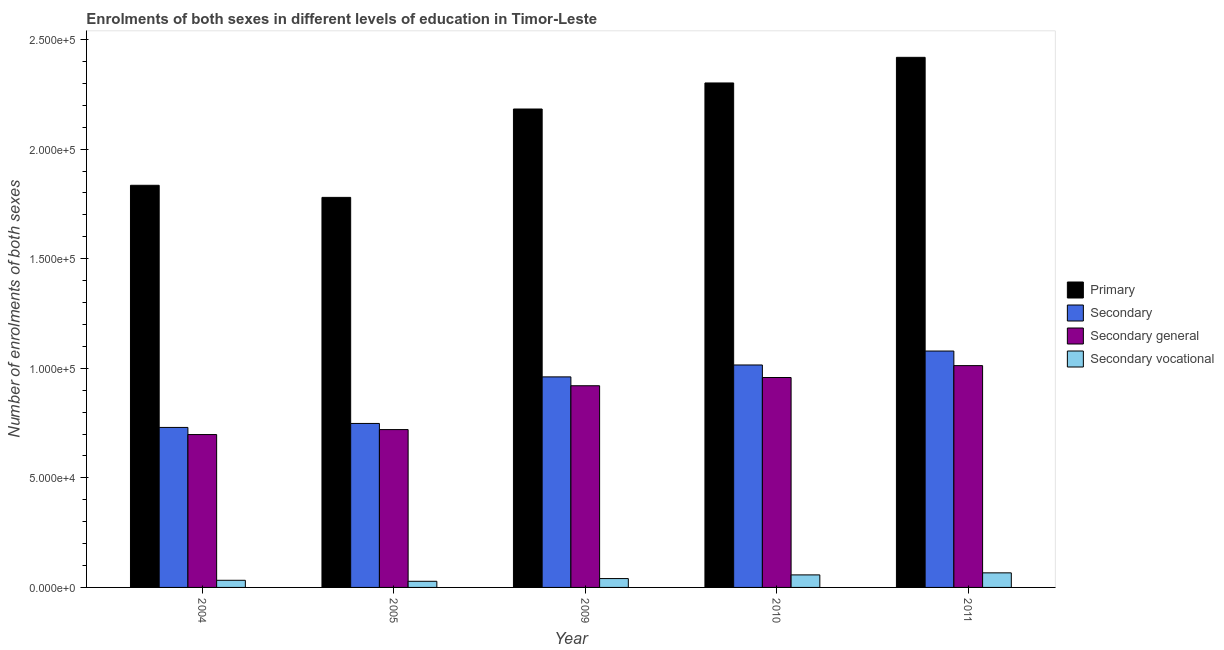Are the number of bars per tick equal to the number of legend labels?
Offer a terse response. Yes. How many bars are there on the 1st tick from the right?
Provide a succinct answer. 4. What is the label of the 5th group of bars from the left?
Offer a very short reply. 2011. What is the number of enrolments in secondary education in 2005?
Ensure brevity in your answer.  7.48e+04. Across all years, what is the maximum number of enrolments in secondary vocational education?
Give a very brief answer. 6649. Across all years, what is the minimum number of enrolments in secondary vocational education?
Ensure brevity in your answer.  2800. In which year was the number of enrolments in secondary general education maximum?
Give a very brief answer. 2011. What is the total number of enrolments in secondary vocational education in the graph?
Your answer should be compact. 2.25e+04. What is the difference between the number of enrolments in secondary education in 2004 and that in 2010?
Offer a terse response. -2.85e+04. What is the difference between the number of enrolments in secondary general education in 2009 and the number of enrolments in primary education in 2004?
Keep it short and to the point. 2.23e+04. What is the average number of enrolments in primary education per year?
Your response must be concise. 2.10e+05. In how many years, is the number of enrolments in secondary education greater than 200000?
Give a very brief answer. 0. What is the ratio of the number of enrolments in secondary education in 2004 to that in 2011?
Keep it short and to the point. 0.68. Is the number of enrolments in secondary vocational education in 2010 less than that in 2011?
Provide a short and direct response. Yes. What is the difference between the highest and the second highest number of enrolments in primary education?
Ensure brevity in your answer.  1.17e+04. What is the difference between the highest and the lowest number of enrolments in primary education?
Your answer should be very brief. 6.39e+04. What does the 1st bar from the left in 2010 represents?
Offer a terse response. Primary. What does the 2nd bar from the right in 2010 represents?
Your response must be concise. Secondary general. Is it the case that in every year, the sum of the number of enrolments in primary education and number of enrolments in secondary education is greater than the number of enrolments in secondary general education?
Provide a short and direct response. Yes. How many bars are there?
Provide a succinct answer. 20. Are all the bars in the graph horizontal?
Offer a very short reply. No. How many years are there in the graph?
Offer a very short reply. 5. What is the difference between two consecutive major ticks on the Y-axis?
Keep it short and to the point. 5.00e+04. Are the values on the major ticks of Y-axis written in scientific E-notation?
Your answer should be compact. Yes. Does the graph contain any zero values?
Your answer should be compact. No. What is the title of the graph?
Ensure brevity in your answer.  Enrolments of both sexes in different levels of education in Timor-Leste. What is the label or title of the Y-axis?
Offer a very short reply. Number of enrolments of both sexes. What is the Number of enrolments of both sexes in Primary in 2004?
Offer a terse response. 1.83e+05. What is the Number of enrolments of both sexes of Secondary in 2004?
Your answer should be very brief. 7.30e+04. What is the Number of enrolments of both sexes of Secondary general in 2004?
Offer a very short reply. 6.98e+04. What is the Number of enrolments of both sexes in Secondary vocational in 2004?
Give a very brief answer. 3253. What is the Number of enrolments of both sexes of Primary in 2005?
Make the answer very short. 1.78e+05. What is the Number of enrolments of both sexes in Secondary in 2005?
Keep it short and to the point. 7.48e+04. What is the Number of enrolments of both sexes in Secondary general in 2005?
Your answer should be compact. 7.20e+04. What is the Number of enrolments of both sexes of Secondary vocational in 2005?
Your answer should be very brief. 2800. What is the Number of enrolments of both sexes of Primary in 2009?
Offer a terse response. 2.18e+05. What is the Number of enrolments of both sexes of Secondary in 2009?
Your answer should be very brief. 9.61e+04. What is the Number of enrolments of both sexes of Secondary general in 2009?
Offer a very short reply. 9.20e+04. What is the Number of enrolments of both sexes in Secondary vocational in 2009?
Ensure brevity in your answer.  4044. What is the Number of enrolments of both sexes of Primary in 2010?
Your response must be concise. 2.30e+05. What is the Number of enrolments of both sexes of Secondary in 2010?
Your answer should be very brief. 1.02e+05. What is the Number of enrolments of both sexes in Secondary general in 2010?
Offer a terse response. 9.58e+04. What is the Number of enrolments of both sexes in Secondary vocational in 2010?
Offer a terse response. 5719. What is the Number of enrolments of both sexes of Primary in 2011?
Provide a short and direct response. 2.42e+05. What is the Number of enrolments of both sexes in Secondary in 2011?
Provide a succinct answer. 1.08e+05. What is the Number of enrolments of both sexes of Secondary general in 2011?
Your answer should be compact. 1.01e+05. What is the Number of enrolments of both sexes of Secondary vocational in 2011?
Give a very brief answer. 6649. Across all years, what is the maximum Number of enrolments of both sexes in Primary?
Your answer should be compact. 2.42e+05. Across all years, what is the maximum Number of enrolments of both sexes in Secondary?
Keep it short and to the point. 1.08e+05. Across all years, what is the maximum Number of enrolments of both sexes of Secondary general?
Provide a short and direct response. 1.01e+05. Across all years, what is the maximum Number of enrolments of both sexes of Secondary vocational?
Your response must be concise. 6649. Across all years, what is the minimum Number of enrolments of both sexes of Primary?
Give a very brief answer. 1.78e+05. Across all years, what is the minimum Number of enrolments of both sexes in Secondary?
Keep it short and to the point. 7.30e+04. Across all years, what is the minimum Number of enrolments of both sexes in Secondary general?
Your answer should be compact. 6.98e+04. Across all years, what is the minimum Number of enrolments of both sexes of Secondary vocational?
Your answer should be very brief. 2800. What is the total Number of enrolments of both sexes in Primary in the graph?
Make the answer very short. 1.05e+06. What is the total Number of enrolments of both sexes in Secondary in the graph?
Make the answer very short. 4.53e+05. What is the total Number of enrolments of both sexes of Secondary general in the graph?
Keep it short and to the point. 4.31e+05. What is the total Number of enrolments of both sexes in Secondary vocational in the graph?
Ensure brevity in your answer.  2.25e+04. What is the difference between the Number of enrolments of both sexes of Primary in 2004 and that in 2005?
Keep it short and to the point. 5513. What is the difference between the Number of enrolments of both sexes of Secondary in 2004 and that in 2005?
Your answer should be compact. -1817. What is the difference between the Number of enrolments of both sexes of Secondary general in 2004 and that in 2005?
Your response must be concise. -2270. What is the difference between the Number of enrolments of both sexes in Secondary vocational in 2004 and that in 2005?
Ensure brevity in your answer.  453. What is the difference between the Number of enrolments of both sexes in Primary in 2004 and that in 2009?
Offer a very short reply. -3.48e+04. What is the difference between the Number of enrolments of both sexes of Secondary in 2004 and that in 2009?
Offer a terse response. -2.31e+04. What is the difference between the Number of enrolments of both sexes of Secondary general in 2004 and that in 2009?
Offer a very short reply. -2.23e+04. What is the difference between the Number of enrolments of both sexes of Secondary vocational in 2004 and that in 2009?
Make the answer very short. -791. What is the difference between the Number of enrolments of both sexes of Primary in 2004 and that in 2010?
Offer a terse response. -4.67e+04. What is the difference between the Number of enrolments of both sexes of Secondary in 2004 and that in 2010?
Your answer should be very brief. -2.85e+04. What is the difference between the Number of enrolments of both sexes in Secondary general in 2004 and that in 2010?
Your answer should be compact. -2.60e+04. What is the difference between the Number of enrolments of both sexes of Secondary vocational in 2004 and that in 2010?
Ensure brevity in your answer.  -2466. What is the difference between the Number of enrolments of both sexes of Primary in 2004 and that in 2011?
Offer a very short reply. -5.84e+04. What is the difference between the Number of enrolments of both sexes in Secondary in 2004 and that in 2011?
Offer a very short reply. -3.49e+04. What is the difference between the Number of enrolments of both sexes in Secondary general in 2004 and that in 2011?
Offer a terse response. -3.15e+04. What is the difference between the Number of enrolments of both sexes in Secondary vocational in 2004 and that in 2011?
Keep it short and to the point. -3396. What is the difference between the Number of enrolments of both sexes in Primary in 2005 and that in 2009?
Make the answer very short. -4.03e+04. What is the difference between the Number of enrolments of both sexes in Secondary in 2005 and that in 2009?
Your answer should be very brief. -2.12e+04. What is the difference between the Number of enrolments of both sexes of Secondary general in 2005 and that in 2009?
Keep it short and to the point. -2.00e+04. What is the difference between the Number of enrolments of both sexes in Secondary vocational in 2005 and that in 2009?
Keep it short and to the point. -1244. What is the difference between the Number of enrolments of both sexes in Primary in 2005 and that in 2010?
Provide a succinct answer. -5.22e+04. What is the difference between the Number of enrolments of both sexes in Secondary in 2005 and that in 2010?
Give a very brief answer. -2.67e+04. What is the difference between the Number of enrolments of both sexes in Secondary general in 2005 and that in 2010?
Give a very brief answer. -2.38e+04. What is the difference between the Number of enrolments of both sexes of Secondary vocational in 2005 and that in 2010?
Provide a short and direct response. -2919. What is the difference between the Number of enrolments of both sexes of Primary in 2005 and that in 2011?
Make the answer very short. -6.39e+04. What is the difference between the Number of enrolments of both sexes of Secondary in 2005 and that in 2011?
Ensure brevity in your answer.  -3.30e+04. What is the difference between the Number of enrolments of both sexes in Secondary general in 2005 and that in 2011?
Your response must be concise. -2.92e+04. What is the difference between the Number of enrolments of both sexes of Secondary vocational in 2005 and that in 2011?
Keep it short and to the point. -3849. What is the difference between the Number of enrolments of both sexes of Primary in 2009 and that in 2010?
Provide a short and direct response. -1.19e+04. What is the difference between the Number of enrolments of both sexes of Secondary in 2009 and that in 2010?
Provide a short and direct response. -5434. What is the difference between the Number of enrolments of both sexes in Secondary general in 2009 and that in 2010?
Provide a short and direct response. -3759. What is the difference between the Number of enrolments of both sexes of Secondary vocational in 2009 and that in 2010?
Give a very brief answer. -1675. What is the difference between the Number of enrolments of both sexes of Primary in 2009 and that in 2011?
Your answer should be compact. -2.36e+04. What is the difference between the Number of enrolments of both sexes in Secondary in 2009 and that in 2011?
Offer a very short reply. -1.18e+04. What is the difference between the Number of enrolments of both sexes of Secondary general in 2009 and that in 2011?
Keep it short and to the point. -9187. What is the difference between the Number of enrolments of both sexes of Secondary vocational in 2009 and that in 2011?
Give a very brief answer. -2605. What is the difference between the Number of enrolments of both sexes of Primary in 2010 and that in 2011?
Your answer should be very brief. -1.17e+04. What is the difference between the Number of enrolments of both sexes in Secondary in 2010 and that in 2011?
Your answer should be very brief. -6358. What is the difference between the Number of enrolments of both sexes in Secondary general in 2010 and that in 2011?
Offer a very short reply. -5428. What is the difference between the Number of enrolments of both sexes of Secondary vocational in 2010 and that in 2011?
Your answer should be very brief. -930. What is the difference between the Number of enrolments of both sexes of Primary in 2004 and the Number of enrolments of both sexes of Secondary in 2005?
Keep it short and to the point. 1.09e+05. What is the difference between the Number of enrolments of both sexes of Primary in 2004 and the Number of enrolments of both sexes of Secondary general in 2005?
Offer a terse response. 1.11e+05. What is the difference between the Number of enrolments of both sexes in Primary in 2004 and the Number of enrolments of both sexes in Secondary vocational in 2005?
Keep it short and to the point. 1.81e+05. What is the difference between the Number of enrolments of both sexes of Secondary in 2004 and the Number of enrolments of both sexes of Secondary general in 2005?
Offer a terse response. 983. What is the difference between the Number of enrolments of both sexes of Secondary in 2004 and the Number of enrolments of both sexes of Secondary vocational in 2005?
Offer a terse response. 7.02e+04. What is the difference between the Number of enrolments of both sexes of Secondary general in 2004 and the Number of enrolments of both sexes of Secondary vocational in 2005?
Make the answer very short. 6.70e+04. What is the difference between the Number of enrolments of both sexes of Primary in 2004 and the Number of enrolments of both sexes of Secondary in 2009?
Offer a very short reply. 8.74e+04. What is the difference between the Number of enrolments of both sexes of Primary in 2004 and the Number of enrolments of both sexes of Secondary general in 2009?
Your answer should be compact. 9.15e+04. What is the difference between the Number of enrolments of both sexes of Primary in 2004 and the Number of enrolments of both sexes of Secondary vocational in 2009?
Provide a succinct answer. 1.79e+05. What is the difference between the Number of enrolments of both sexes in Secondary in 2004 and the Number of enrolments of both sexes in Secondary general in 2009?
Give a very brief answer. -1.90e+04. What is the difference between the Number of enrolments of both sexes of Secondary in 2004 and the Number of enrolments of both sexes of Secondary vocational in 2009?
Your response must be concise. 6.90e+04. What is the difference between the Number of enrolments of both sexes in Secondary general in 2004 and the Number of enrolments of both sexes in Secondary vocational in 2009?
Give a very brief answer. 6.57e+04. What is the difference between the Number of enrolments of both sexes in Primary in 2004 and the Number of enrolments of both sexes in Secondary in 2010?
Your response must be concise. 8.20e+04. What is the difference between the Number of enrolments of both sexes in Primary in 2004 and the Number of enrolments of both sexes in Secondary general in 2010?
Your response must be concise. 8.77e+04. What is the difference between the Number of enrolments of both sexes in Primary in 2004 and the Number of enrolments of both sexes in Secondary vocational in 2010?
Offer a very short reply. 1.78e+05. What is the difference between the Number of enrolments of both sexes of Secondary in 2004 and the Number of enrolments of both sexes of Secondary general in 2010?
Give a very brief answer. -2.28e+04. What is the difference between the Number of enrolments of both sexes of Secondary in 2004 and the Number of enrolments of both sexes of Secondary vocational in 2010?
Make the answer very short. 6.73e+04. What is the difference between the Number of enrolments of both sexes of Secondary general in 2004 and the Number of enrolments of both sexes of Secondary vocational in 2010?
Offer a very short reply. 6.40e+04. What is the difference between the Number of enrolments of both sexes of Primary in 2004 and the Number of enrolments of both sexes of Secondary in 2011?
Provide a short and direct response. 7.56e+04. What is the difference between the Number of enrolments of both sexes in Primary in 2004 and the Number of enrolments of both sexes in Secondary general in 2011?
Offer a very short reply. 8.23e+04. What is the difference between the Number of enrolments of both sexes in Primary in 2004 and the Number of enrolments of both sexes in Secondary vocational in 2011?
Your answer should be compact. 1.77e+05. What is the difference between the Number of enrolments of both sexes of Secondary in 2004 and the Number of enrolments of both sexes of Secondary general in 2011?
Provide a succinct answer. -2.82e+04. What is the difference between the Number of enrolments of both sexes of Secondary in 2004 and the Number of enrolments of both sexes of Secondary vocational in 2011?
Your answer should be very brief. 6.64e+04. What is the difference between the Number of enrolments of both sexes of Secondary general in 2004 and the Number of enrolments of both sexes of Secondary vocational in 2011?
Your response must be concise. 6.31e+04. What is the difference between the Number of enrolments of both sexes of Primary in 2005 and the Number of enrolments of both sexes of Secondary in 2009?
Keep it short and to the point. 8.19e+04. What is the difference between the Number of enrolments of both sexes of Primary in 2005 and the Number of enrolments of both sexes of Secondary general in 2009?
Give a very brief answer. 8.59e+04. What is the difference between the Number of enrolments of both sexes of Primary in 2005 and the Number of enrolments of both sexes of Secondary vocational in 2009?
Provide a short and direct response. 1.74e+05. What is the difference between the Number of enrolments of both sexes in Secondary in 2005 and the Number of enrolments of both sexes in Secondary general in 2009?
Offer a very short reply. -1.72e+04. What is the difference between the Number of enrolments of both sexes of Secondary in 2005 and the Number of enrolments of both sexes of Secondary vocational in 2009?
Your response must be concise. 7.08e+04. What is the difference between the Number of enrolments of both sexes of Secondary general in 2005 and the Number of enrolments of both sexes of Secondary vocational in 2009?
Your answer should be compact. 6.80e+04. What is the difference between the Number of enrolments of both sexes in Primary in 2005 and the Number of enrolments of both sexes in Secondary in 2010?
Offer a very short reply. 7.65e+04. What is the difference between the Number of enrolments of both sexes in Primary in 2005 and the Number of enrolments of both sexes in Secondary general in 2010?
Provide a succinct answer. 8.22e+04. What is the difference between the Number of enrolments of both sexes in Primary in 2005 and the Number of enrolments of both sexes in Secondary vocational in 2010?
Provide a short and direct response. 1.72e+05. What is the difference between the Number of enrolments of both sexes of Secondary in 2005 and the Number of enrolments of both sexes of Secondary general in 2010?
Make the answer very short. -2.10e+04. What is the difference between the Number of enrolments of both sexes in Secondary in 2005 and the Number of enrolments of both sexes in Secondary vocational in 2010?
Offer a terse response. 6.91e+04. What is the difference between the Number of enrolments of both sexes of Secondary general in 2005 and the Number of enrolments of both sexes of Secondary vocational in 2010?
Your answer should be very brief. 6.63e+04. What is the difference between the Number of enrolments of both sexes in Primary in 2005 and the Number of enrolments of both sexes in Secondary in 2011?
Keep it short and to the point. 7.01e+04. What is the difference between the Number of enrolments of both sexes in Primary in 2005 and the Number of enrolments of both sexes in Secondary general in 2011?
Offer a terse response. 7.68e+04. What is the difference between the Number of enrolments of both sexes of Primary in 2005 and the Number of enrolments of both sexes of Secondary vocational in 2011?
Your answer should be very brief. 1.71e+05. What is the difference between the Number of enrolments of both sexes in Secondary in 2005 and the Number of enrolments of both sexes in Secondary general in 2011?
Give a very brief answer. -2.64e+04. What is the difference between the Number of enrolments of both sexes of Secondary in 2005 and the Number of enrolments of both sexes of Secondary vocational in 2011?
Offer a terse response. 6.82e+04. What is the difference between the Number of enrolments of both sexes of Secondary general in 2005 and the Number of enrolments of both sexes of Secondary vocational in 2011?
Your answer should be compact. 6.54e+04. What is the difference between the Number of enrolments of both sexes of Primary in 2009 and the Number of enrolments of both sexes of Secondary in 2010?
Provide a short and direct response. 1.17e+05. What is the difference between the Number of enrolments of both sexes of Primary in 2009 and the Number of enrolments of both sexes of Secondary general in 2010?
Your response must be concise. 1.23e+05. What is the difference between the Number of enrolments of both sexes of Primary in 2009 and the Number of enrolments of both sexes of Secondary vocational in 2010?
Keep it short and to the point. 2.13e+05. What is the difference between the Number of enrolments of both sexes in Secondary in 2009 and the Number of enrolments of both sexes in Secondary general in 2010?
Keep it short and to the point. 285. What is the difference between the Number of enrolments of both sexes of Secondary in 2009 and the Number of enrolments of both sexes of Secondary vocational in 2010?
Your answer should be very brief. 9.03e+04. What is the difference between the Number of enrolments of both sexes in Secondary general in 2009 and the Number of enrolments of both sexes in Secondary vocational in 2010?
Your response must be concise. 8.63e+04. What is the difference between the Number of enrolments of both sexes of Primary in 2009 and the Number of enrolments of both sexes of Secondary in 2011?
Your answer should be very brief. 1.10e+05. What is the difference between the Number of enrolments of both sexes of Primary in 2009 and the Number of enrolments of both sexes of Secondary general in 2011?
Make the answer very short. 1.17e+05. What is the difference between the Number of enrolments of both sexes of Primary in 2009 and the Number of enrolments of both sexes of Secondary vocational in 2011?
Provide a succinct answer. 2.12e+05. What is the difference between the Number of enrolments of both sexes of Secondary in 2009 and the Number of enrolments of both sexes of Secondary general in 2011?
Keep it short and to the point. -5143. What is the difference between the Number of enrolments of both sexes of Secondary in 2009 and the Number of enrolments of both sexes of Secondary vocational in 2011?
Keep it short and to the point. 8.94e+04. What is the difference between the Number of enrolments of both sexes in Secondary general in 2009 and the Number of enrolments of both sexes in Secondary vocational in 2011?
Give a very brief answer. 8.54e+04. What is the difference between the Number of enrolments of both sexes of Primary in 2010 and the Number of enrolments of both sexes of Secondary in 2011?
Offer a very short reply. 1.22e+05. What is the difference between the Number of enrolments of both sexes of Primary in 2010 and the Number of enrolments of both sexes of Secondary general in 2011?
Provide a short and direct response. 1.29e+05. What is the difference between the Number of enrolments of both sexes of Primary in 2010 and the Number of enrolments of both sexes of Secondary vocational in 2011?
Provide a short and direct response. 2.24e+05. What is the difference between the Number of enrolments of both sexes of Secondary in 2010 and the Number of enrolments of both sexes of Secondary general in 2011?
Provide a succinct answer. 291. What is the difference between the Number of enrolments of both sexes of Secondary in 2010 and the Number of enrolments of both sexes of Secondary vocational in 2011?
Give a very brief answer. 9.49e+04. What is the difference between the Number of enrolments of both sexes in Secondary general in 2010 and the Number of enrolments of both sexes in Secondary vocational in 2011?
Provide a succinct answer. 8.91e+04. What is the average Number of enrolments of both sexes of Primary per year?
Your response must be concise. 2.10e+05. What is the average Number of enrolments of both sexes of Secondary per year?
Keep it short and to the point. 9.07e+04. What is the average Number of enrolments of both sexes of Secondary general per year?
Your answer should be compact. 8.62e+04. What is the average Number of enrolments of both sexes of Secondary vocational per year?
Provide a succinct answer. 4493. In the year 2004, what is the difference between the Number of enrolments of both sexes in Primary and Number of enrolments of both sexes in Secondary?
Give a very brief answer. 1.10e+05. In the year 2004, what is the difference between the Number of enrolments of both sexes of Primary and Number of enrolments of both sexes of Secondary general?
Offer a terse response. 1.14e+05. In the year 2004, what is the difference between the Number of enrolments of both sexes of Primary and Number of enrolments of both sexes of Secondary vocational?
Give a very brief answer. 1.80e+05. In the year 2004, what is the difference between the Number of enrolments of both sexes of Secondary and Number of enrolments of both sexes of Secondary general?
Provide a succinct answer. 3253. In the year 2004, what is the difference between the Number of enrolments of both sexes of Secondary and Number of enrolments of both sexes of Secondary vocational?
Give a very brief answer. 6.98e+04. In the year 2004, what is the difference between the Number of enrolments of both sexes of Secondary general and Number of enrolments of both sexes of Secondary vocational?
Your response must be concise. 6.65e+04. In the year 2005, what is the difference between the Number of enrolments of both sexes in Primary and Number of enrolments of both sexes in Secondary?
Offer a terse response. 1.03e+05. In the year 2005, what is the difference between the Number of enrolments of both sexes in Primary and Number of enrolments of both sexes in Secondary general?
Offer a very short reply. 1.06e+05. In the year 2005, what is the difference between the Number of enrolments of both sexes of Primary and Number of enrolments of both sexes of Secondary vocational?
Keep it short and to the point. 1.75e+05. In the year 2005, what is the difference between the Number of enrolments of both sexes of Secondary and Number of enrolments of both sexes of Secondary general?
Your response must be concise. 2800. In the year 2005, what is the difference between the Number of enrolments of both sexes of Secondary and Number of enrolments of both sexes of Secondary vocational?
Your answer should be compact. 7.20e+04. In the year 2005, what is the difference between the Number of enrolments of both sexes in Secondary general and Number of enrolments of both sexes in Secondary vocational?
Offer a very short reply. 6.92e+04. In the year 2009, what is the difference between the Number of enrolments of both sexes of Primary and Number of enrolments of both sexes of Secondary?
Make the answer very short. 1.22e+05. In the year 2009, what is the difference between the Number of enrolments of both sexes of Primary and Number of enrolments of both sexes of Secondary general?
Offer a terse response. 1.26e+05. In the year 2009, what is the difference between the Number of enrolments of both sexes of Primary and Number of enrolments of both sexes of Secondary vocational?
Make the answer very short. 2.14e+05. In the year 2009, what is the difference between the Number of enrolments of both sexes of Secondary and Number of enrolments of both sexes of Secondary general?
Your response must be concise. 4044. In the year 2009, what is the difference between the Number of enrolments of both sexes of Secondary and Number of enrolments of both sexes of Secondary vocational?
Provide a short and direct response. 9.20e+04. In the year 2009, what is the difference between the Number of enrolments of both sexes in Secondary general and Number of enrolments of both sexes in Secondary vocational?
Your answer should be very brief. 8.80e+04. In the year 2010, what is the difference between the Number of enrolments of both sexes in Primary and Number of enrolments of both sexes in Secondary?
Offer a very short reply. 1.29e+05. In the year 2010, what is the difference between the Number of enrolments of both sexes of Primary and Number of enrolments of both sexes of Secondary general?
Give a very brief answer. 1.34e+05. In the year 2010, what is the difference between the Number of enrolments of both sexes in Primary and Number of enrolments of both sexes in Secondary vocational?
Offer a very short reply. 2.24e+05. In the year 2010, what is the difference between the Number of enrolments of both sexes in Secondary and Number of enrolments of both sexes in Secondary general?
Provide a succinct answer. 5719. In the year 2010, what is the difference between the Number of enrolments of both sexes in Secondary and Number of enrolments of both sexes in Secondary vocational?
Give a very brief answer. 9.58e+04. In the year 2010, what is the difference between the Number of enrolments of both sexes in Secondary general and Number of enrolments of both sexes in Secondary vocational?
Make the answer very short. 9.01e+04. In the year 2011, what is the difference between the Number of enrolments of both sexes in Primary and Number of enrolments of both sexes in Secondary?
Give a very brief answer. 1.34e+05. In the year 2011, what is the difference between the Number of enrolments of both sexes of Primary and Number of enrolments of both sexes of Secondary general?
Your answer should be compact. 1.41e+05. In the year 2011, what is the difference between the Number of enrolments of both sexes in Primary and Number of enrolments of both sexes in Secondary vocational?
Your answer should be compact. 2.35e+05. In the year 2011, what is the difference between the Number of enrolments of both sexes of Secondary and Number of enrolments of both sexes of Secondary general?
Your response must be concise. 6649. In the year 2011, what is the difference between the Number of enrolments of both sexes in Secondary and Number of enrolments of both sexes in Secondary vocational?
Give a very brief answer. 1.01e+05. In the year 2011, what is the difference between the Number of enrolments of both sexes of Secondary general and Number of enrolments of both sexes of Secondary vocational?
Provide a short and direct response. 9.46e+04. What is the ratio of the Number of enrolments of both sexes of Primary in 2004 to that in 2005?
Give a very brief answer. 1.03. What is the ratio of the Number of enrolments of both sexes of Secondary in 2004 to that in 2005?
Your response must be concise. 0.98. What is the ratio of the Number of enrolments of both sexes of Secondary general in 2004 to that in 2005?
Offer a terse response. 0.97. What is the ratio of the Number of enrolments of both sexes of Secondary vocational in 2004 to that in 2005?
Your answer should be very brief. 1.16. What is the ratio of the Number of enrolments of both sexes in Primary in 2004 to that in 2009?
Give a very brief answer. 0.84. What is the ratio of the Number of enrolments of both sexes of Secondary in 2004 to that in 2009?
Give a very brief answer. 0.76. What is the ratio of the Number of enrolments of both sexes in Secondary general in 2004 to that in 2009?
Your answer should be very brief. 0.76. What is the ratio of the Number of enrolments of both sexes in Secondary vocational in 2004 to that in 2009?
Ensure brevity in your answer.  0.8. What is the ratio of the Number of enrolments of both sexes of Primary in 2004 to that in 2010?
Offer a terse response. 0.8. What is the ratio of the Number of enrolments of both sexes in Secondary in 2004 to that in 2010?
Your answer should be very brief. 0.72. What is the ratio of the Number of enrolments of both sexes of Secondary general in 2004 to that in 2010?
Keep it short and to the point. 0.73. What is the ratio of the Number of enrolments of both sexes of Secondary vocational in 2004 to that in 2010?
Your answer should be very brief. 0.57. What is the ratio of the Number of enrolments of both sexes in Primary in 2004 to that in 2011?
Give a very brief answer. 0.76. What is the ratio of the Number of enrolments of both sexes of Secondary in 2004 to that in 2011?
Ensure brevity in your answer.  0.68. What is the ratio of the Number of enrolments of both sexes in Secondary general in 2004 to that in 2011?
Your response must be concise. 0.69. What is the ratio of the Number of enrolments of both sexes in Secondary vocational in 2004 to that in 2011?
Provide a short and direct response. 0.49. What is the ratio of the Number of enrolments of both sexes in Primary in 2005 to that in 2009?
Make the answer very short. 0.82. What is the ratio of the Number of enrolments of both sexes of Secondary in 2005 to that in 2009?
Offer a terse response. 0.78. What is the ratio of the Number of enrolments of both sexes of Secondary general in 2005 to that in 2009?
Provide a succinct answer. 0.78. What is the ratio of the Number of enrolments of both sexes of Secondary vocational in 2005 to that in 2009?
Your answer should be very brief. 0.69. What is the ratio of the Number of enrolments of both sexes of Primary in 2005 to that in 2010?
Your response must be concise. 0.77. What is the ratio of the Number of enrolments of both sexes in Secondary in 2005 to that in 2010?
Provide a short and direct response. 0.74. What is the ratio of the Number of enrolments of both sexes in Secondary general in 2005 to that in 2010?
Make the answer very short. 0.75. What is the ratio of the Number of enrolments of both sexes in Secondary vocational in 2005 to that in 2010?
Your answer should be very brief. 0.49. What is the ratio of the Number of enrolments of both sexes of Primary in 2005 to that in 2011?
Offer a very short reply. 0.74. What is the ratio of the Number of enrolments of both sexes in Secondary in 2005 to that in 2011?
Your answer should be compact. 0.69. What is the ratio of the Number of enrolments of both sexes in Secondary general in 2005 to that in 2011?
Ensure brevity in your answer.  0.71. What is the ratio of the Number of enrolments of both sexes in Secondary vocational in 2005 to that in 2011?
Offer a very short reply. 0.42. What is the ratio of the Number of enrolments of both sexes of Primary in 2009 to that in 2010?
Make the answer very short. 0.95. What is the ratio of the Number of enrolments of both sexes in Secondary in 2009 to that in 2010?
Your response must be concise. 0.95. What is the ratio of the Number of enrolments of both sexes of Secondary general in 2009 to that in 2010?
Offer a very short reply. 0.96. What is the ratio of the Number of enrolments of both sexes of Secondary vocational in 2009 to that in 2010?
Make the answer very short. 0.71. What is the ratio of the Number of enrolments of both sexes in Primary in 2009 to that in 2011?
Give a very brief answer. 0.9. What is the ratio of the Number of enrolments of both sexes in Secondary in 2009 to that in 2011?
Give a very brief answer. 0.89. What is the ratio of the Number of enrolments of both sexes of Secondary general in 2009 to that in 2011?
Ensure brevity in your answer.  0.91. What is the ratio of the Number of enrolments of both sexes of Secondary vocational in 2009 to that in 2011?
Your response must be concise. 0.61. What is the ratio of the Number of enrolments of both sexes of Primary in 2010 to that in 2011?
Your answer should be very brief. 0.95. What is the ratio of the Number of enrolments of both sexes of Secondary in 2010 to that in 2011?
Your answer should be compact. 0.94. What is the ratio of the Number of enrolments of both sexes in Secondary general in 2010 to that in 2011?
Provide a short and direct response. 0.95. What is the ratio of the Number of enrolments of both sexes in Secondary vocational in 2010 to that in 2011?
Give a very brief answer. 0.86. What is the difference between the highest and the second highest Number of enrolments of both sexes in Primary?
Offer a terse response. 1.17e+04. What is the difference between the highest and the second highest Number of enrolments of both sexes of Secondary?
Provide a short and direct response. 6358. What is the difference between the highest and the second highest Number of enrolments of both sexes of Secondary general?
Offer a terse response. 5428. What is the difference between the highest and the second highest Number of enrolments of both sexes in Secondary vocational?
Provide a short and direct response. 930. What is the difference between the highest and the lowest Number of enrolments of both sexes of Primary?
Provide a short and direct response. 6.39e+04. What is the difference between the highest and the lowest Number of enrolments of both sexes of Secondary?
Your answer should be very brief. 3.49e+04. What is the difference between the highest and the lowest Number of enrolments of both sexes in Secondary general?
Your answer should be compact. 3.15e+04. What is the difference between the highest and the lowest Number of enrolments of both sexes of Secondary vocational?
Keep it short and to the point. 3849. 